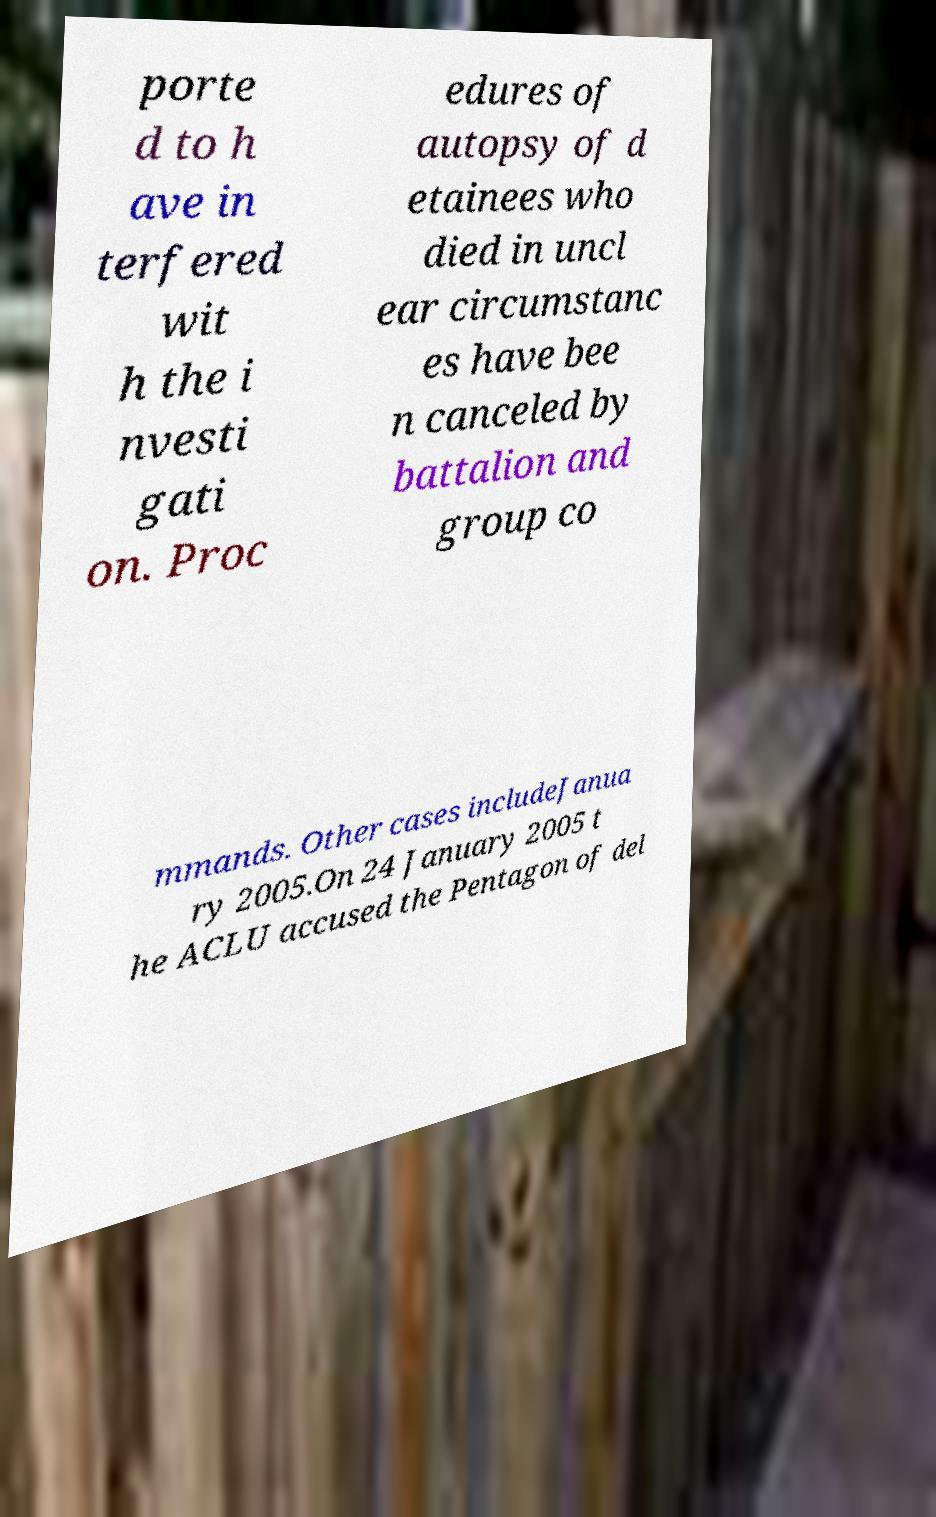Please identify and transcribe the text found in this image. porte d to h ave in terfered wit h the i nvesti gati on. Proc edures of autopsy of d etainees who died in uncl ear circumstanc es have bee n canceled by battalion and group co mmands. Other cases includeJanua ry 2005.On 24 January 2005 t he ACLU accused the Pentagon of del 